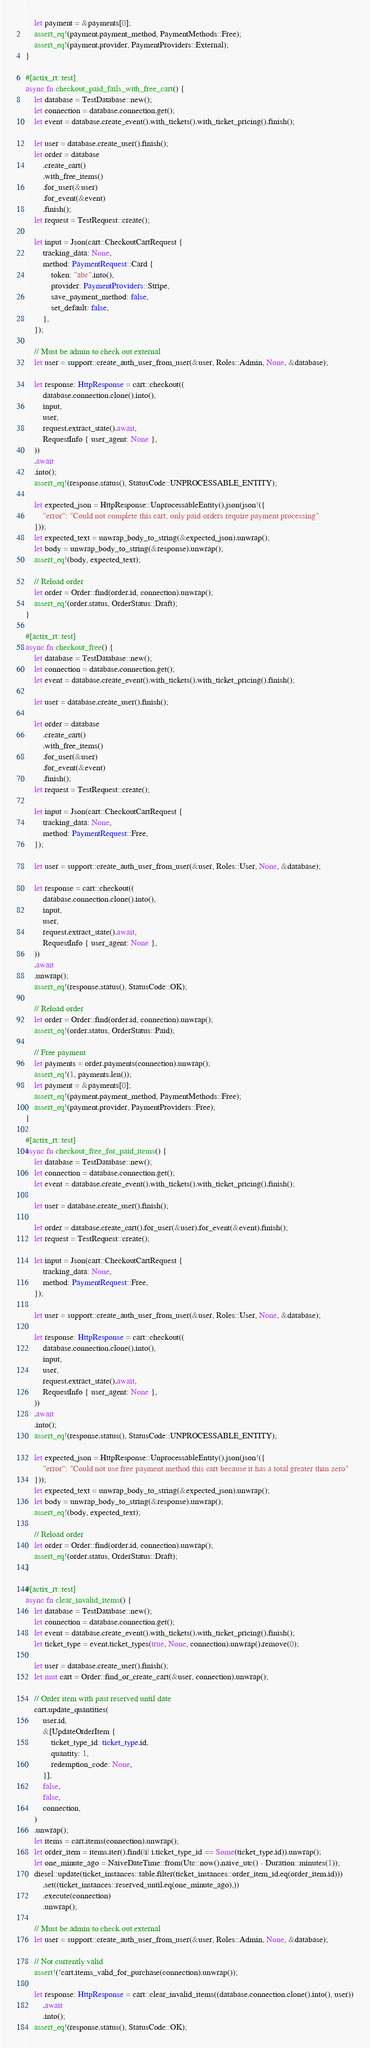<code> <loc_0><loc_0><loc_500><loc_500><_Rust_>    let payment = &payments[0];
    assert_eq!(payment.payment_method, PaymentMethods::Free);
    assert_eq!(payment.provider, PaymentProviders::External);
}

#[actix_rt::test]
async fn checkout_paid_fails_with_free_cart() {
    let database = TestDatabase::new();
    let connection = database.connection.get();
    let event = database.create_event().with_tickets().with_ticket_pricing().finish();

    let user = database.create_user().finish();
    let order = database
        .create_cart()
        .with_free_items()
        .for_user(&user)
        .for_event(&event)
        .finish();
    let request = TestRequest::create();

    let input = Json(cart::CheckoutCartRequest {
        tracking_data: None,
        method: PaymentRequest::Card {
            token: "abc".into(),
            provider: PaymentProviders::Stripe,
            save_payment_method: false,
            set_default: false,
        },
    });

    // Must be admin to check out external
    let user = support::create_auth_user_from_user(&user, Roles::Admin, None, &database);

    let response: HttpResponse = cart::checkout((
        database.connection.clone().into(),
        input,
        user,
        request.extract_state().await,
        RequestInfo { user_agent: None },
    ))
    .await
    .into();
    assert_eq!(response.status(), StatusCode::UNPROCESSABLE_ENTITY);

    let expected_json = HttpResponse::UnprocessableEntity().json(json!({
        "error": "Could not complete this cart; only paid orders require payment processing"
    }));
    let expected_text = unwrap_body_to_string(&expected_json).unwrap();
    let body = unwrap_body_to_string(&response).unwrap();
    assert_eq!(body, expected_text);

    // Reload order
    let order = Order::find(order.id, connection).unwrap();
    assert_eq!(order.status, OrderStatus::Draft);
}

#[actix_rt::test]
async fn checkout_free() {
    let database = TestDatabase::new();
    let connection = database.connection.get();
    let event = database.create_event().with_tickets().with_ticket_pricing().finish();

    let user = database.create_user().finish();

    let order = database
        .create_cart()
        .with_free_items()
        .for_user(&user)
        .for_event(&event)
        .finish();
    let request = TestRequest::create();

    let input = Json(cart::CheckoutCartRequest {
        tracking_data: None,
        method: PaymentRequest::Free,
    });

    let user = support::create_auth_user_from_user(&user, Roles::User, None, &database);

    let response = cart::checkout((
        database.connection.clone().into(),
        input,
        user,
        request.extract_state().await,
        RequestInfo { user_agent: None },
    ))
    .await
    .unwrap();
    assert_eq!(response.status(), StatusCode::OK);

    // Reload order
    let order = Order::find(order.id, connection).unwrap();
    assert_eq!(order.status, OrderStatus::Paid);

    // Free payment
    let payments = order.payments(connection).unwrap();
    assert_eq!(1, payments.len());
    let payment = &payments[0];
    assert_eq!(payment.payment_method, PaymentMethods::Free);
    assert_eq!(payment.provider, PaymentProviders::Free);
}

#[actix_rt::test]
async fn checkout_free_for_paid_items() {
    let database = TestDatabase::new();
    let connection = database.connection.get();
    let event = database.create_event().with_tickets().with_ticket_pricing().finish();

    let user = database.create_user().finish();

    let order = database.create_cart().for_user(&user).for_event(&event).finish();
    let request = TestRequest::create();

    let input = Json(cart::CheckoutCartRequest {
        tracking_data: None,
        method: PaymentRequest::Free,
    });

    let user = support::create_auth_user_from_user(&user, Roles::User, None, &database);

    let response: HttpResponse = cart::checkout((
        database.connection.clone().into(),
        input,
        user,
        request.extract_state().await,
        RequestInfo { user_agent: None },
    ))
    .await
    .into();
    assert_eq!(response.status(), StatusCode::UNPROCESSABLE_ENTITY);

    let expected_json = HttpResponse::UnprocessableEntity().json(json!({
        "error": "Could not use free payment method this cart because it has a total greater than zero"
    }));
    let expected_text = unwrap_body_to_string(&expected_json).unwrap();
    let body = unwrap_body_to_string(&response).unwrap();
    assert_eq!(body, expected_text);

    // Reload order
    let order = Order::find(order.id, connection).unwrap();
    assert_eq!(order.status, OrderStatus::Draft);
}

#[actix_rt::test]
async fn clear_invalid_items() {
    let database = TestDatabase::new();
    let connection = database.connection.get();
    let event = database.create_event().with_tickets().with_ticket_pricing().finish();
    let ticket_type = event.ticket_types(true, None, connection).unwrap().remove(0);

    let user = database.create_user().finish();
    let mut cart = Order::find_or_create_cart(&user, connection).unwrap();

    // Order item with past reserved until date
    cart.update_quantities(
        user.id,
        &[UpdateOrderItem {
            ticket_type_id: ticket_type.id,
            quantity: 1,
            redemption_code: None,
        }],
        false,
        false,
        connection,
    )
    .unwrap();
    let items = cart.items(connection).unwrap();
    let order_item = items.iter().find(|i| i.ticket_type_id == Some(ticket_type.id)).unwrap();
    let one_minute_ago = NaiveDateTime::from(Utc::now().naive_utc() - Duration::minutes(1));
    diesel::update(ticket_instances::table.filter(ticket_instances::order_item_id.eq(order_item.id)))
        .set((ticket_instances::reserved_until.eq(one_minute_ago),))
        .execute(connection)
        .unwrap();

    // Must be admin to check out external
    let user = support::create_auth_user_from_user(&user, Roles::Admin, None, &database);

    // Not currently valid
    assert!(!cart.items_valid_for_purchase(connection).unwrap());

    let response: HttpResponse = cart::clear_invalid_items((database.connection.clone().into(), user))
        .await
        .into();
    assert_eq!(response.status(), StatusCode::OK);
</code> 